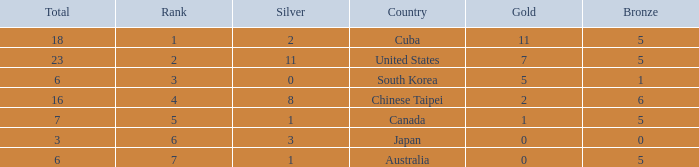Write the full table. {'header': ['Total', 'Rank', 'Silver', 'Country', 'Gold', 'Bronze'], 'rows': [['18', '1', '2', 'Cuba', '11', '5'], ['23', '2', '11', 'United States', '7', '5'], ['6', '3', '0', 'South Korea', '5', '1'], ['16', '4', '8', 'Chinese Taipei', '2', '6'], ['7', '5', '1', 'Canada', '1', '5'], ['3', '6', '3', 'Japan', '0', '0'], ['6', '7', '1', 'Australia', '0', '5']]} What is the sum of the bronze medals when there were more than 2 silver medals and a rank larger than 6? None. 